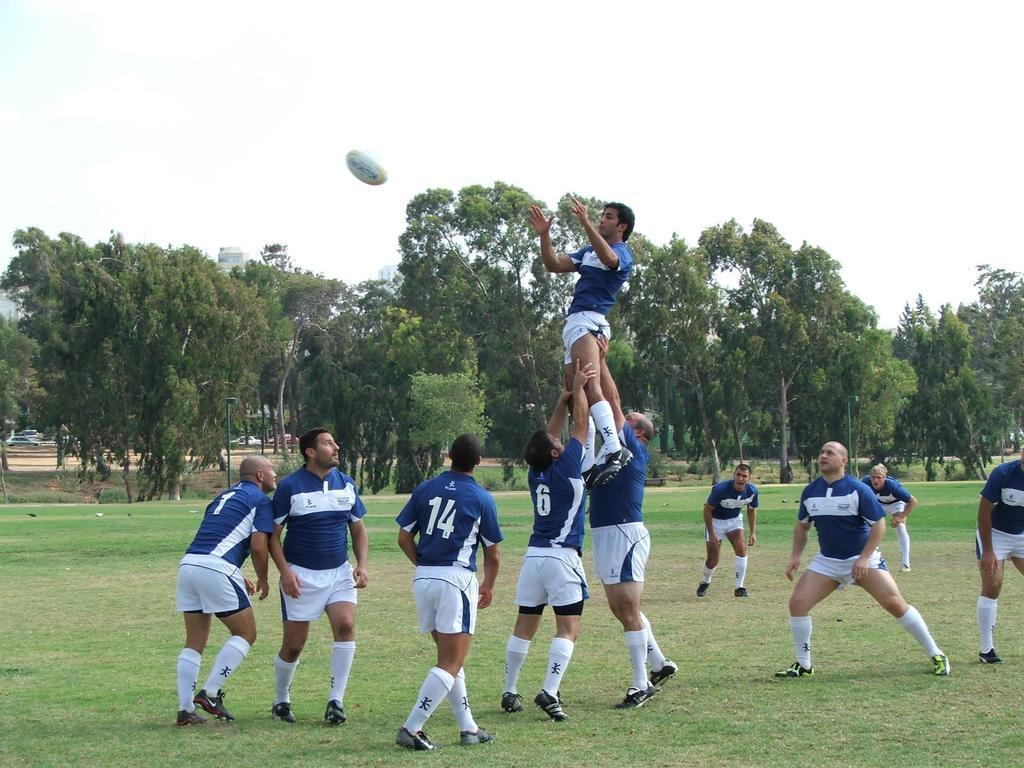Provide a one-sentence caption for the provided image. A group of rugby players sportin the numbers 14, 6 and 1 among others. 